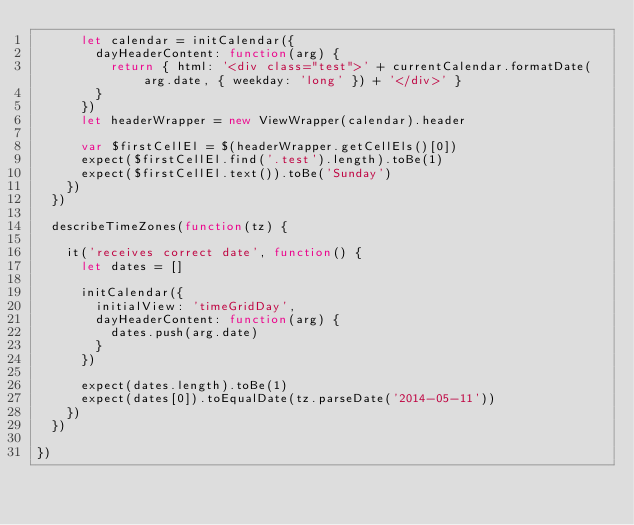<code> <loc_0><loc_0><loc_500><loc_500><_JavaScript_>      let calendar = initCalendar({
        dayHeaderContent: function(arg) {
          return { html: '<div class="test">' + currentCalendar.formatDate(arg.date, { weekday: 'long' }) + '</div>' }
        }
      })
      let headerWrapper = new ViewWrapper(calendar).header

      var $firstCellEl = $(headerWrapper.getCellEls()[0])
      expect($firstCellEl.find('.test').length).toBe(1)
      expect($firstCellEl.text()).toBe('Sunday')
    })
  })

  describeTimeZones(function(tz) {

    it('receives correct date', function() {
      let dates = []

      initCalendar({
        initialView: 'timeGridDay',
        dayHeaderContent: function(arg) {
          dates.push(arg.date)
        }
      })

      expect(dates.length).toBe(1)
      expect(dates[0]).toEqualDate(tz.parseDate('2014-05-11'))
    })
  })

})
</code> 